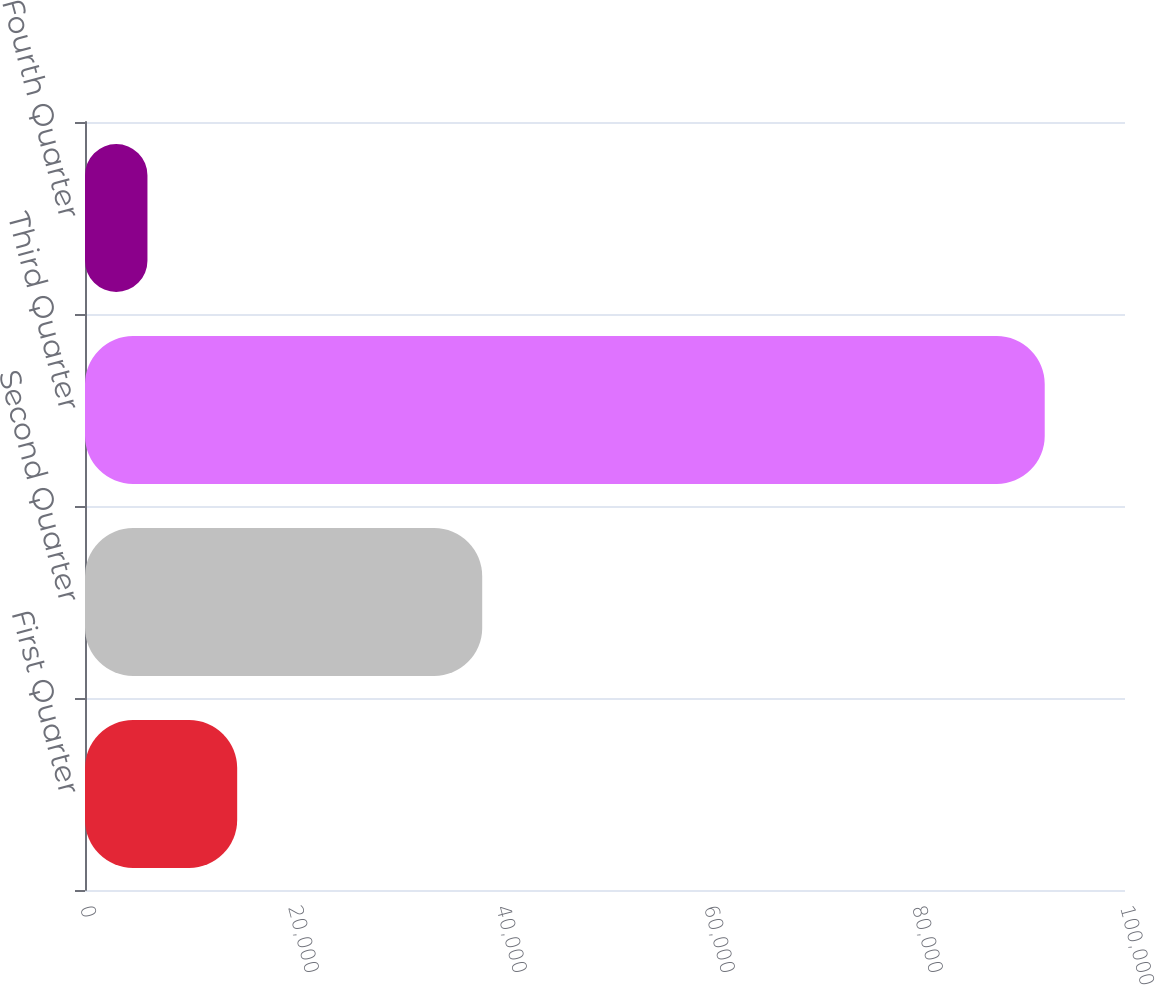<chart> <loc_0><loc_0><loc_500><loc_500><bar_chart><fcel>First Quarter<fcel>Second Quarter<fcel>Third Quarter<fcel>Fourth Quarter<nl><fcel>14632.6<fcel>38193<fcel>92281<fcel>6005<nl></chart> 